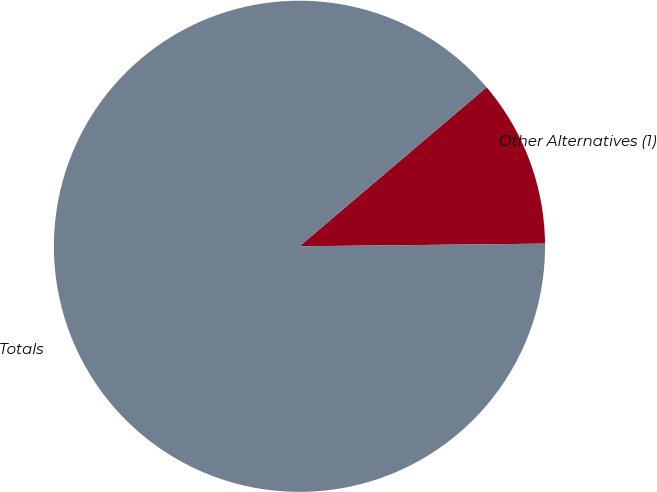<chart> <loc_0><loc_0><loc_500><loc_500><pie_chart><fcel>Other Alternatives (1)<fcel>Totals<nl><fcel>11.04%<fcel>88.96%<nl></chart> 